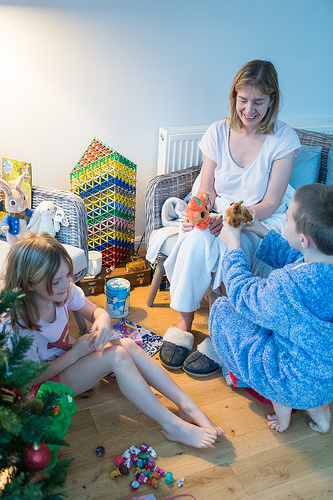<image>
Can you confirm if the slippers is on the girl? No. The slippers is not positioned on the girl. They may be near each other, but the slippers is not supported by or resting on top of the girl. Where is the rabbit in relation to the girl? Is it behind the girl? Yes. From this viewpoint, the rabbit is positioned behind the girl, with the girl partially or fully occluding the rabbit. 